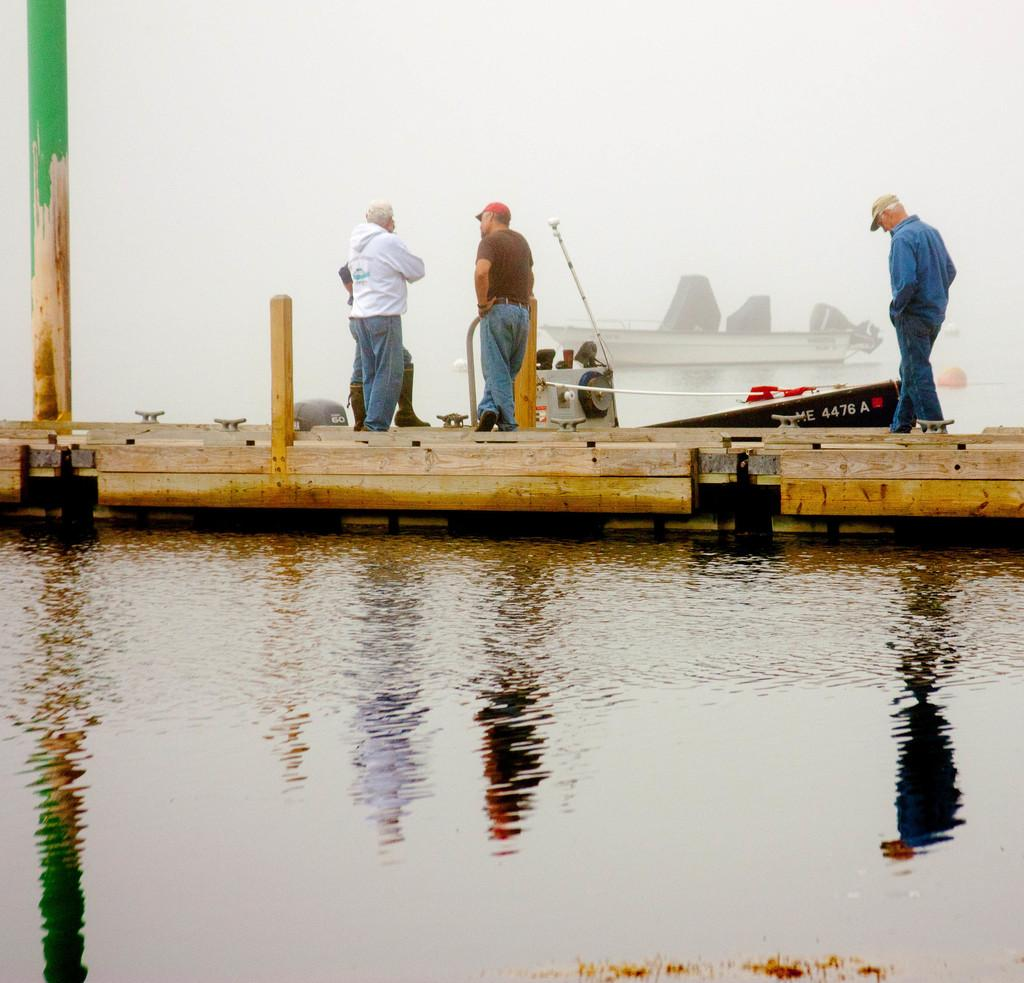What type of vehicles are in the image? There are boats in the image. Are there any people on the boats? Yes, there are people standing on the boat. What is visible at the bottom of the image? There is water visible at the bottom of the image. Reasoning: Let' Let's think step by step in order to produce the conversation. We start by identifying the main subject in the image, which are the boats. Then, we expand the conversation to include the people on the boats and the water visible at the bottom of the image. Each question is designed to elicit a specific detail about the image that is known from the provided facts. Absurd Question/Answer: What type of offer can be seen being made by the people on the boat? There is no offer being made by the people on the boat in the image. Can you describe the smiles of the people on the boat? There is no mention of smiles in the image, as the focus is on the boats and the water. 